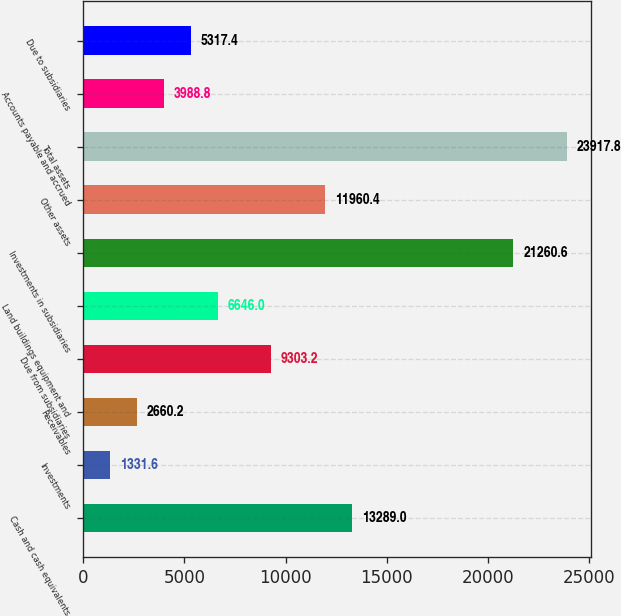Convert chart. <chart><loc_0><loc_0><loc_500><loc_500><bar_chart><fcel>Cash and cash equivalents<fcel>Investments<fcel>Receivables<fcel>Due from subsidiaries<fcel>Land buildings equipment and<fcel>Investments in subsidiaries<fcel>Other assets<fcel>Total assets<fcel>Accounts payable and accrued<fcel>Due to subsidiaries<nl><fcel>13289<fcel>1331.6<fcel>2660.2<fcel>9303.2<fcel>6646<fcel>21260.6<fcel>11960.4<fcel>23917.8<fcel>3988.8<fcel>5317.4<nl></chart> 